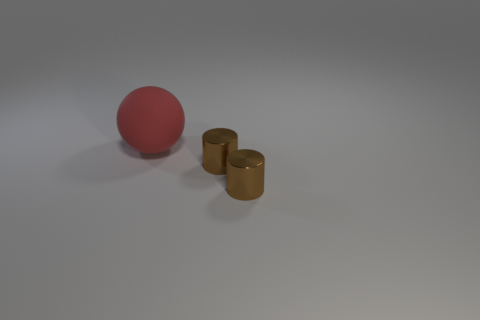Are there any cylinders that have the same color as the rubber sphere?
Your response must be concise. No. How many things are either big red matte objects or cyan cylinders?
Offer a terse response. 1. What number of objects are either tiny metallic cylinders or objects on the right side of the red thing?
Ensure brevity in your answer.  2. The rubber sphere is what color?
Provide a short and direct response. Red. Is there anything else that has the same color as the big matte sphere?
Ensure brevity in your answer.  No. Is the number of tiny objects that are behind the red matte object greater than the number of tiny gray rubber objects?
Provide a succinct answer. No. How big is the ball?
Provide a succinct answer. Large. Are there any small objects in front of the red sphere?
Provide a short and direct response. Yes. The large object is what shape?
Keep it short and to the point. Sphere. What number of large things are the same color as the big rubber sphere?
Provide a succinct answer. 0. 